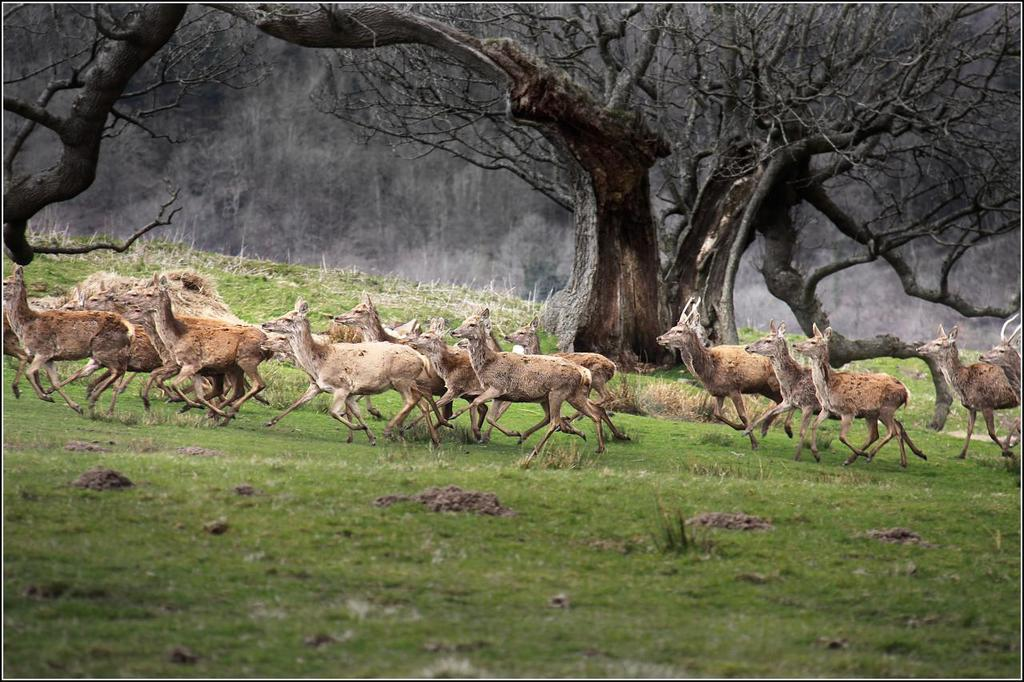What animals can be seen in the image? There are deers in the image. What is the deers' position in relation to the ground? The deers are standing on the ground. What type of vegetation covers the ground in the image? The ground is covered with grass. What can be seen in the distance behind the deers? There are trees visible in the background of the image. What type of toothbrush is the deer using in the image? There is no toothbrush present in the image, and the deers are not using any toothbrushes. 